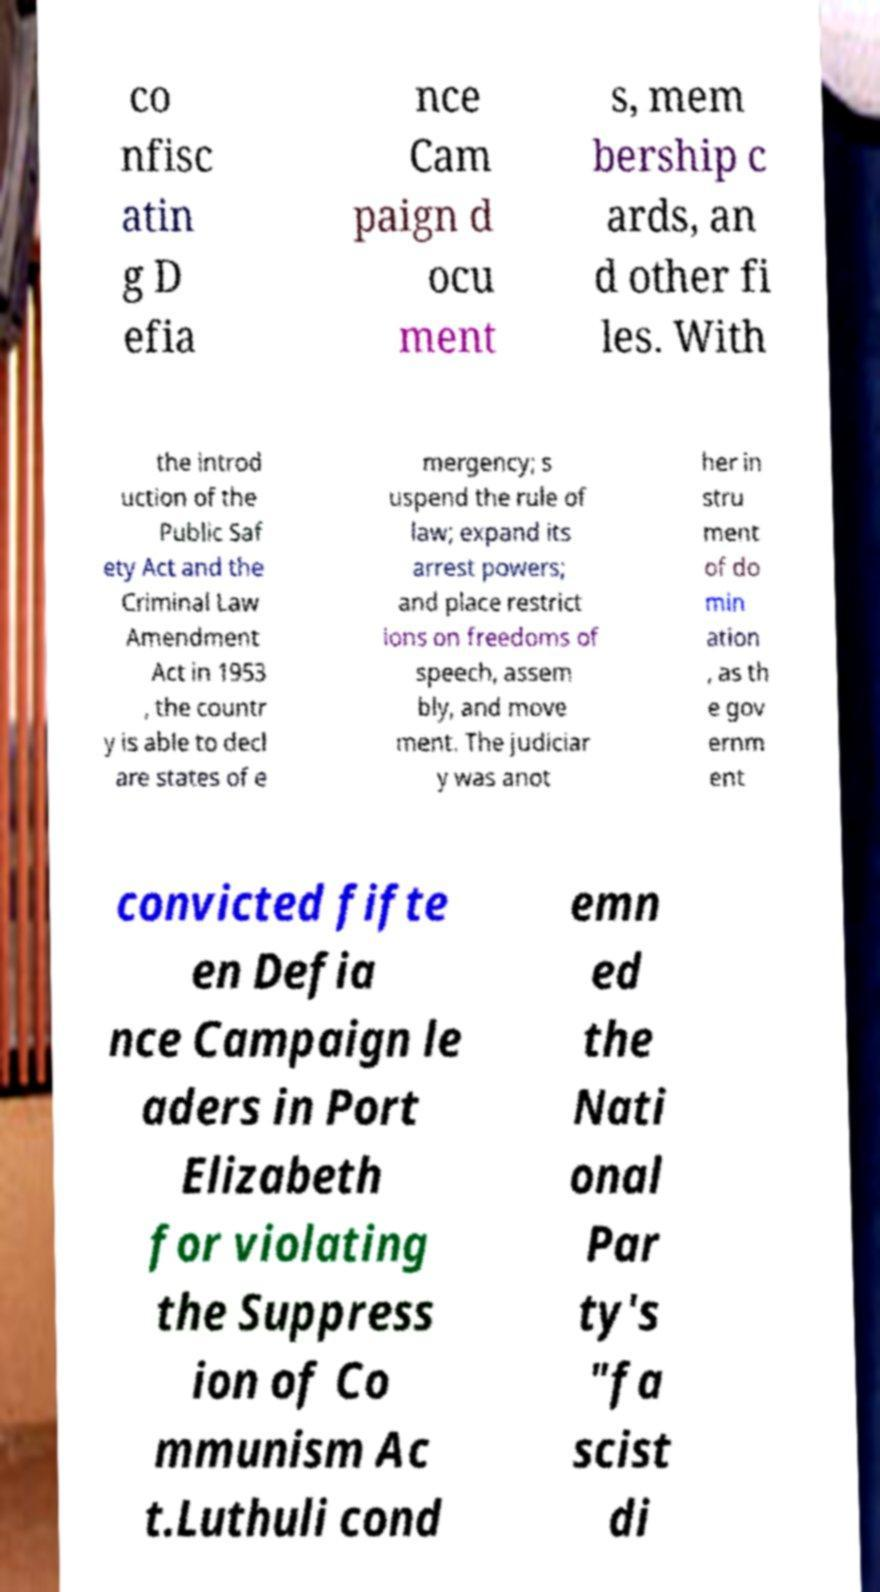Can you accurately transcribe the text from the provided image for me? co nfisc atin g D efia nce Cam paign d ocu ment s, mem bership c ards, an d other fi les. With the introd uction of the Public Saf ety Act and the Criminal Law Amendment Act in 1953 , the countr y is able to decl are states of e mergency; s uspend the rule of law; expand its arrest powers; and place restrict ions on freedoms of speech, assem bly, and move ment. The judiciar y was anot her in stru ment of do min ation , as th e gov ernm ent convicted fifte en Defia nce Campaign le aders in Port Elizabeth for violating the Suppress ion of Co mmunism Ac t.Luthuli cond emn ed the Nati onal Par ty's "fa scist di 